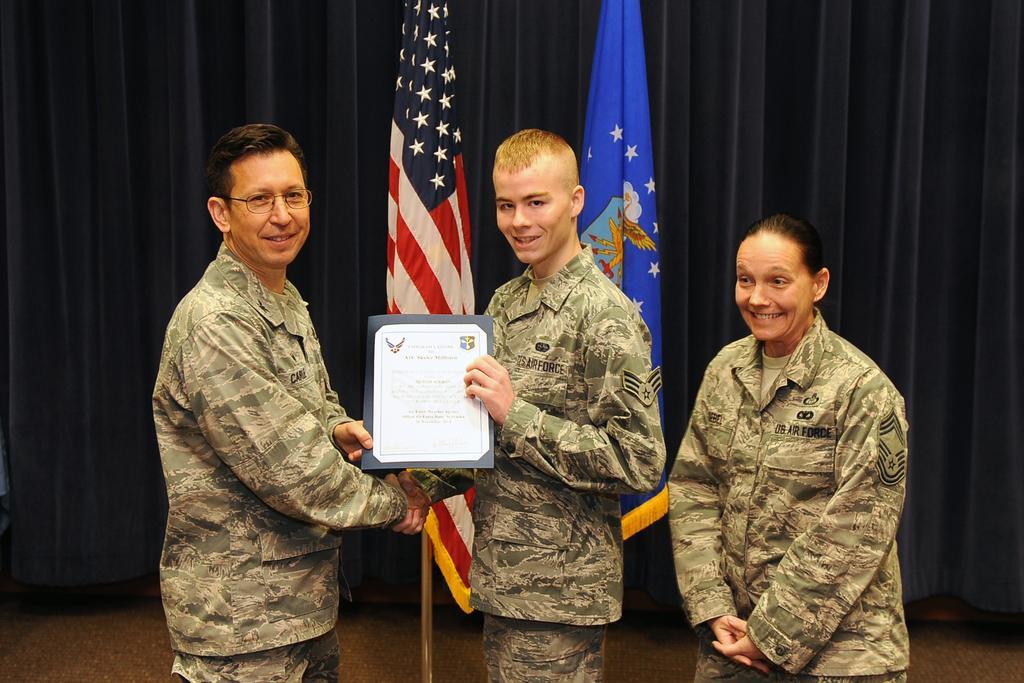In one or two sentences, can you explain what this image depicts? In this image I can see three persons standing. In front the person is holding the certificate. In the background I can see two flags and they are in multi color and I can see few curtains in navy blue color. 